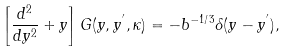Convert formula to latex. <formula><loc_0><loc_0><loc_500><loc_500>\left [ \frac { d ^ { 2 } } { d y ^ { 2 } } + y \right ] G ( y , y ^ { ^ { \prime } } , \kappa ) = - b ^ { - 1 / 3 } \delta ( y - y ^ { ^ { \prime } } ) ,</formula> 